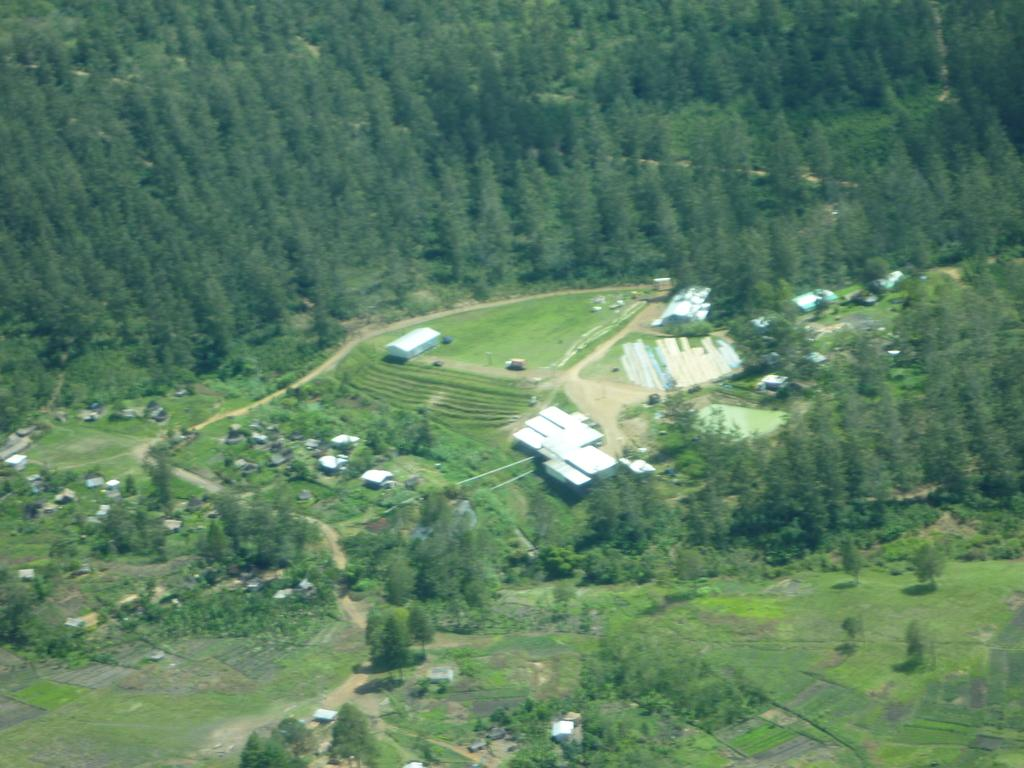What type of vegetation can be seen at the top of the image? There are trees at the top of the image. What type of vegetation can be seen at the bottom of the image? There are trees at the bottom of the image. What type of structures are located in the middle of the image? There are houses in the middle of the image. What type of silk is being used to create knowledge in the image? There is no silk or knowledge present in the image; it features trees at the top and bottom, and houses in the middle. 